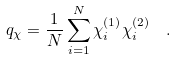<formula> <loc_0><loc_0><loc_500><loc_500>q _ { \chi } = \frac { 1 } { N } \sum _ { i = 1 } ^ { N } \chi _ { i } ^ { ( 1 ) } \chi _ { i } ^ { ( 2 ) } \ \ .</formula> 